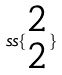<formula> <loc_0><loc_0><loc_500><loc_500>s s \{ \begin{matrix} 2 \\ 2 \end{matrix} \}</formula> 